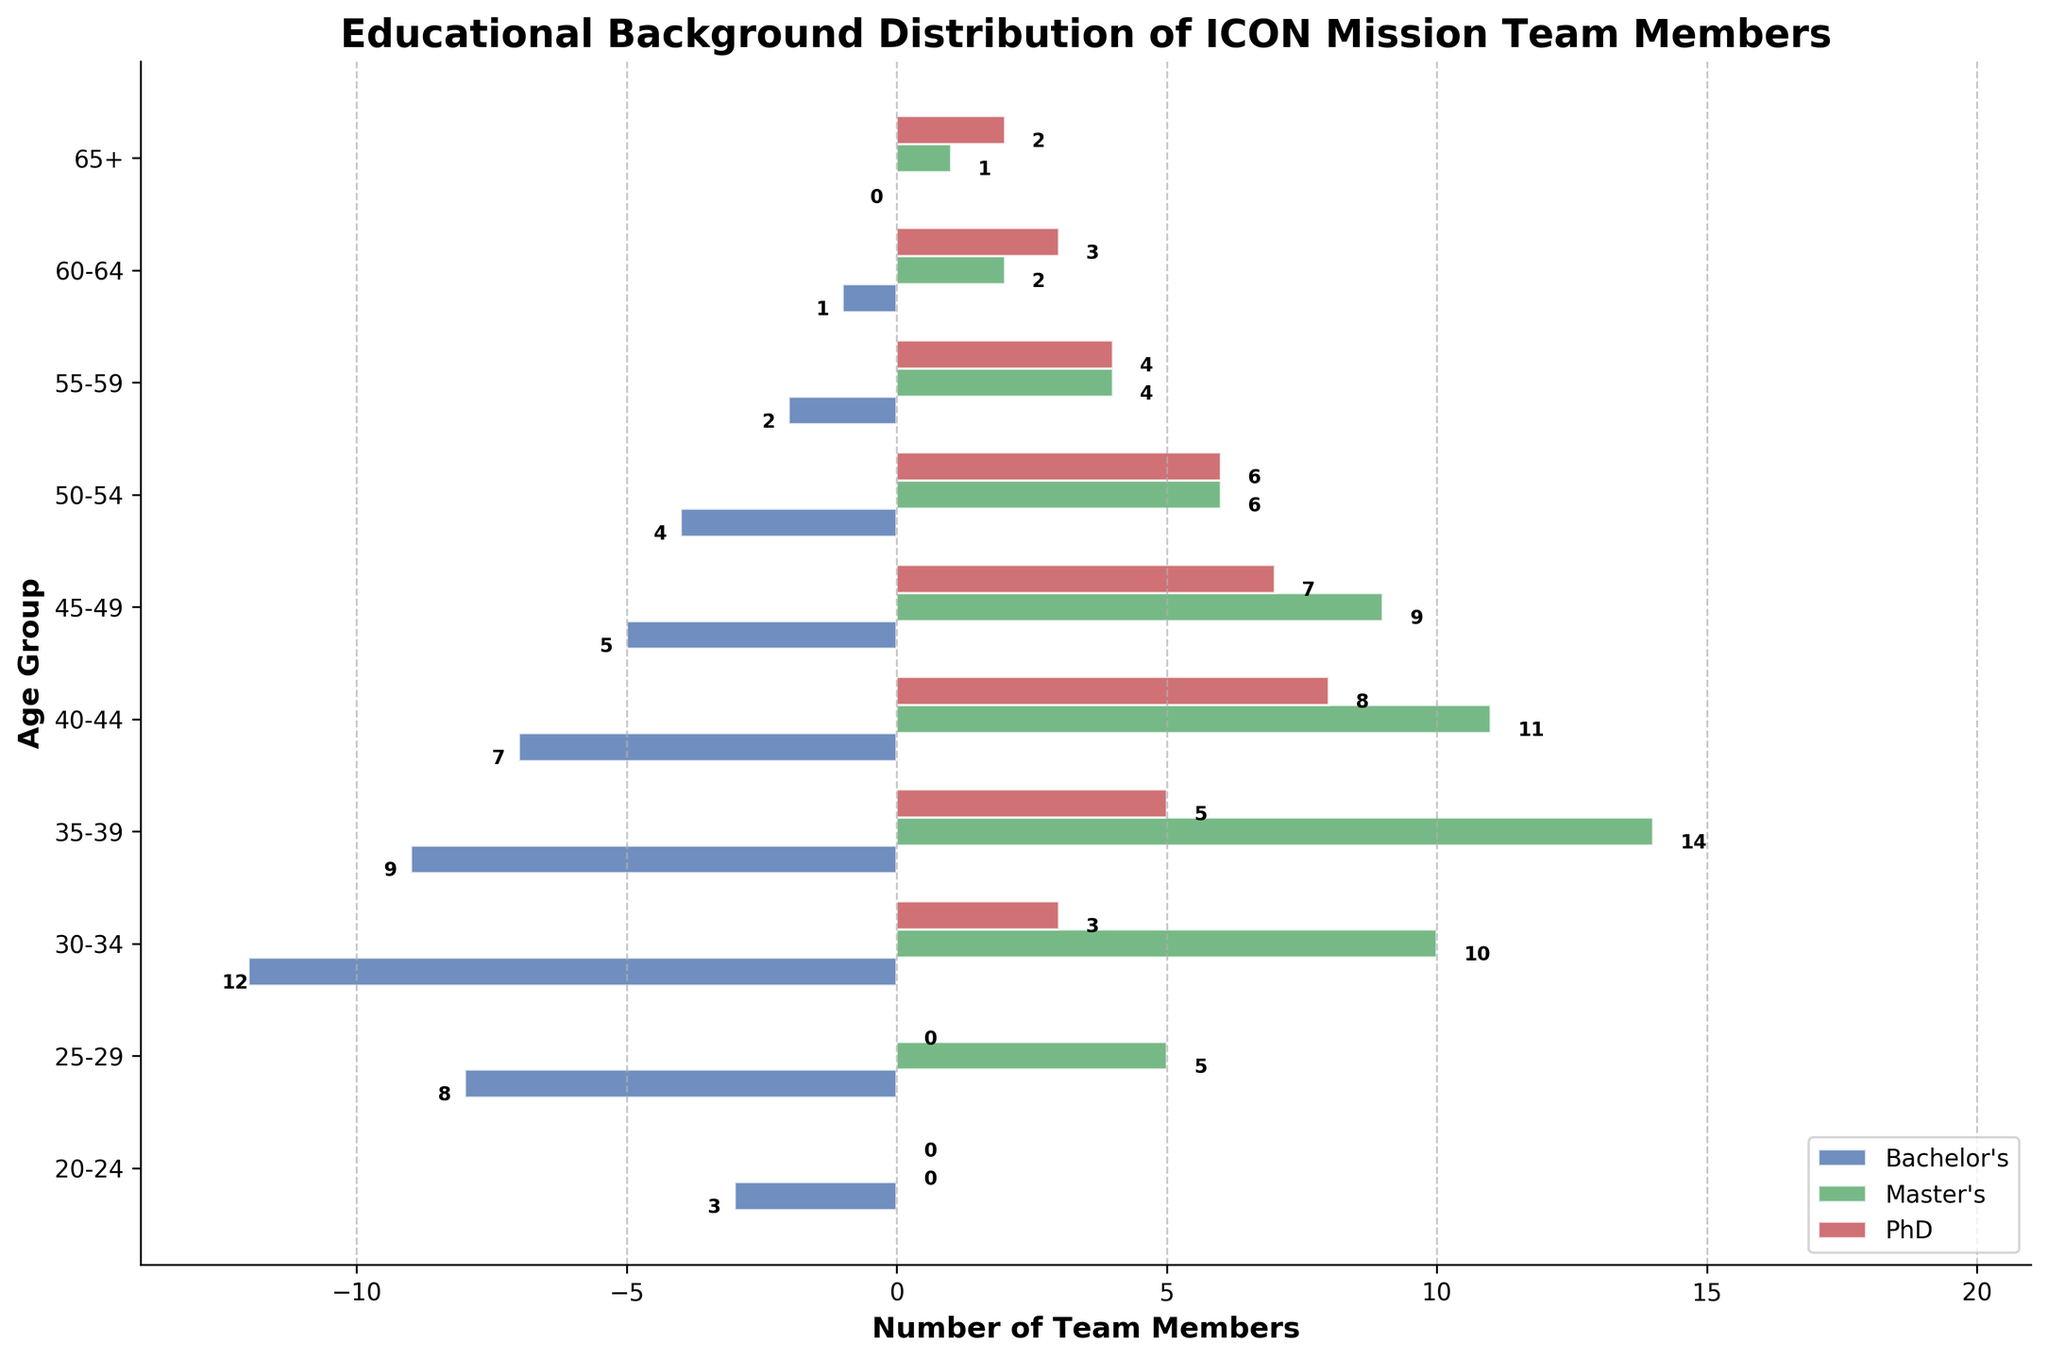How many Master's degree holders are in the 40-44 age group? To determine the number of Master's degree holders in the 40-44 age group, look at the Master's bar (usually colored) for the 40-44 age group and read the corresponding value.
Answer: 11 Which age group has the highest number of Bachelor's degree holders? Identify the Bachelor's bar values across all age groups and determine the one with the highest value.
Answer: 30-34 What is the total number of PhDs in the age groups below 35? Sum the PhD bar values for the 20-24, 25-29, and 30-34 age groups. Calculate 0 + 0 + 3 = 3.
Answer: 3 Are there more team members with a Bachelor's degree or a PhD in the 55-59 age group? Compare the lengths of the Bachelor's and PhD bars for the 55-59 age group. The Bachelor's bar shows 2 and the PhD bar shows 4.
Answer: PhD Which age group has the smallest number of Master's degree holders? Check all Master's bars and identify the age group with the smallest value. The smallest value is 0 for the 20-24 age group.
Answer: 20-24 Do any age groups have an equal number of team members with Master's and PhD degrees? Compare the bar lengths for Master's and PhD degrees within each age group and identify any matches. The 50-54 age group has 6 Master's and 6 PhD degrees.
Answer: 50-54 What is the total number of Bachelor's degree holders across all age groups? Sum the Bachelor's bar values across all age groups. Calculate 3 + 8 + 12 + 9 + 7 + 5 + 4 + 2 + 1 + 0 = 51.
Answer: 51 Which age group has the highest combined total of all degrees? Sum the Bachelor's, Master's, and PhD bar values for each age group and find the group with the highest total. The 35-39 age group has 9 Bachelor's, 14 Master's, and 5 PhD, totaling 28.
Answer: 35-39 In the 60-64 age group, how does the number of team members with Master's degrees compare to those with Bachelor's degrees? Compare the values of the Master's and Bachelor's bars within the 60-64 age group. The Master's bar is 2 and the Bachelor's bar is 1.
Answer: More Master's degrees What is the combined total of team members with a PhD in the age groups 45-49 and 65+? Add the PhD bar values for the 45-49 and 65+ age groups. Calculate 7 + 2 = 9.
Answer: 9 